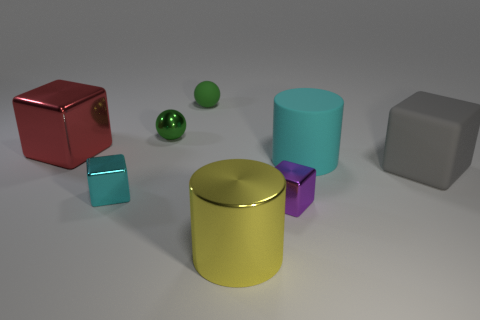What number of big red objects are made of the same material as the purple block? There is only one large red object that appears to be made of the same material as the purple block, which is glossy and seems to reflect light similarly. 